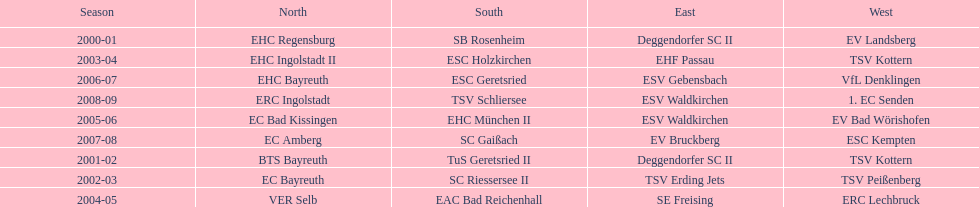The latest team to triumph in the west? 1. EC Senden. 